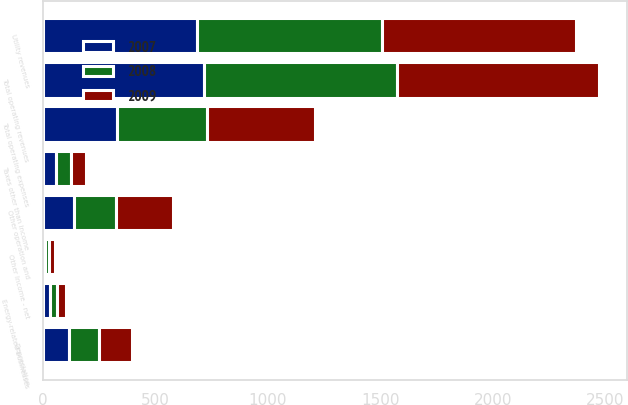Convert chart to OTSL. <chart><loc_0><loc_0><loc_500><loc_500><stacked_bar_chart><ecel><fcel>Utility revenues<fcel>Energy-related businesses<fcel>Total operating revenues<fcel>Other operation and<fcel>Depreciation<fcel>Taxes other than income<fcel>Total operating expenses<fcel>Other Income - net<nl><fcel>2007<fcel>684<fcel>32<fcel>716<fcel>140<fcel>115<fcel>57<fcel>328<fcel>11<nl><fcel>2008<fcel>824<fcel>33<fcel>857<fcel>186<fcel>134<fcel>66<fcel>400<fcel>17<nl><fcel>2009<fcel>863<fcel>37<fcel>900<fcel>252<fcel>147<fcel>67<fcel>483<fcel>26<nl></chart> 